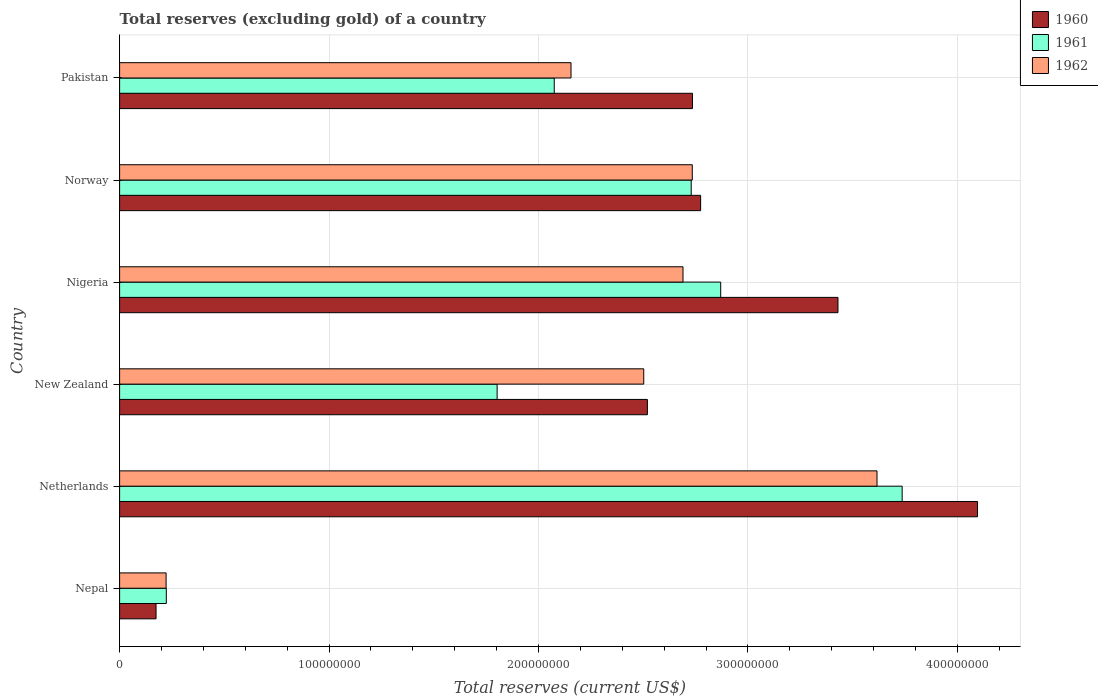Are the number of bars per tick equal to the number of legend labels?
Your response must be concise. Yes. Are the number of bars on each tick of the Y-axis equal?
Provide a succinct answer. Yes. How many bars are there on the 1st tick from the top?
Give a very brief answer. 3. How many bars are there on the 4th tick from the bottom?
Provide a succinct answer. 3. What is the label of the 4th group of bars from the top?
Provide a short and direct response. New Zealand. In how many cases, is the number of bars for a given country not equal to the number of legend labels?
Ensure brevity in your answer.  0. What is the total reserves (excluding gold) in 1960 in Netherlands?
Provide a short and direct response. 4.10e+08. Across all countries, what is the maximum total reserves (excluding gold) in 1960?
Your response must be concise. 4.10e+08. Across all countries, what is the minimum total reserves (excluding gold) in 1960?
Offer a terse response. 1.74e+07. In which country was the total reserves (excluding gold) in 1960 minimum?
Give a very brief answer. Nepal. What is the total total reserves (excluding gold) in 1961 in the graph?
Provide a succinct answer. 1.34e+09. What is the difference between the total reserves (excluding gold) in 1961 in Nepal and that in Netherlands?
Keep it short and to the point. -3.51e+08. What is the difference between the total reserves (excluding gold) in 1961 in New Zealand and the total reserves (excluding gold) in 1962 in Nigeria?
Provide a short and direct response. -8.88e+07. What is the average total reserves (excluding gold) in 1962 per country?
Your response must be concise. 2.32e+08. What is the difference between the total reserves (excluding gold) in 1961 and total reserves (excluding gold) in 1960 in Norway?
Make the answer very short. -4.50e+06. In how many countries, is the total reserves (excluding gold) in 1962 greater than 320000000 US$?
Make the answer very short. 1. What is the ratio of the total reserves (excluding gold) in 1960 in Nepal to that in New Zealand?
Give a very brief answer. 0.07. Is the total reserves (excluding gold) in 1962 in Netherlands less than that in Nigeria?
Offer a terse response. No. What is the difference between the highest and the second highest total reserves (excluding gold) in 1960?
Make the answer very short. 6.66e+07. What is the difference between the highest and the lowest total reserves (excluding gold) in 1961?
Make the answer very short. 3.51e+08. Is the sum of the total reserves (excluding gold) in 1961 in Netherlands and Norway greater than the maximum total reserves (excluding gold) in 1960 across all countries?
Give a very brief answer. Yes. What does the 1st bar from the top in Nigeria represents?
Offer a very short reply. 1962. What does the 3rd bar from the bottom in New Zealand represents?
Provide a succinct answer. 1962. How many bars are there?
Keep it short and to the point. 18. How many countries are there in the graph?
Offer a terse response. 6. What is the difference between two consecutive major ticks on the X-axis?
Offer a very short reply. 1.00e+08. Are the values on the major ticks of X-axis written in scientific E-notation?
Provide a succinct answer. No. Does the graph contain any zero values?
Make the answer very short. No. Does the graph contain grids?
Give a very brief answer. Yes. Where does the legend appear in the graph?
Offer a very short reply. Top right. What is the title of the graph?
Your answer should be compact. Total reserves (excluding gold) of a country. What is the label or title of the X-axis?
Make the answer very short. Total reserves (current US$). What is the Total reserves (current US$) of 1960 in Nepal?
Offer a very short reply. 1.74e+07. What is the Total reserves (current US$) in 1961 in Nepal?
Offer a very short reply. 2.23e+07. What is the Total reserves (current US$) of 1962 in Nepal?
Your answer should be compact. 2.22e+07. What is the Total reserves (current US$) of 1960 in Netherlands?
Ensure brevity in your answer.  4.10e+08. What is the Total reserves (current US$) of 1961 in Netherlands?
Offer a very short reply. 3.74e+08. What is the Total reserves (current US$) in 1962 in Netherlands?
Your answer should be very brief. 3.62e+08. What is the Total reserves (current US$) in 1960 in New Zealand?
Keep it short and to the point. 2.52e+08. What is the Total reserves (current US$) in 1961 in New Zealand?
Offer a terse response. 1.80e+08. What is the Total reserves (current US$) in 1962 in New Zealand?
Offer a very short reply. 2.50e+08. What is the Total reserves (current US$) in 1960 in Nigeria?
Give a very brief answer. 3.43e+08. What is the Total reserves (current US$) in 1961 in Nigeria?
Make the answer very short. 2.87e+08. What is the Total reserves (current US$) of 1962 in Nigeria?
Keep it short and to the point. 2.69e+08. What is the Total reserves (current US$) of 1960 in Norway?
Provide a short and direct response. 2.77e+08. What is the Total reserves (current US$) of 1961 in Norway?
Ensure brevity in your answer.  2.73e+08. What is the Total reserves (current US$) in 1962 in Norway?
Your answer should be compact. 2.73e+08. What is the Total reserves (current US$) in 1960 in Pakistan?
Make the answer very short. 2.74e+08. What is the Total reserves (current US$) in 1961 in Pakistan?
Provide a short and direct response. 2.08e+08. What is the Total reserves (current US$) in 1962 in Pakistan?
Provide a short and direct response. 2.16e+08. Across all countries, what is the maximum Total reserves (current US$) of 1960?
Your answer should be compact. 4.10e+08. Across all countries, what is the maximum Total reserves (current US$) of 1961?
Keep it short and to the point. 3.74e+08. Across all countries, what is the maximum Total reserves (current US$) of 1962?
Keep it short and to the point. 3.62e+08. Across all countries, what is the minimum Total reserves (current US$) in 1960?
Offer a very short reply. 1.74e+07. Across all countries, what is the minimum Total reserves (current US$) of 1961?
Provide a succinct answer. 2.23e+07. Across all countries, what is the minimum Total reserves (current US$) of 1962?
Provide a succinct answer. 2.22e+07. What is the total Total reserves (current US$) of 1960 in the graph?
Make the answer very short. 1.57e+09. What is the total Total reserves (current US$) in 1961 in the graph?
Provide a short and direct response. 1.34e+09. What is the total Total reserves (current US$) of 1962 in the graph?
Your answer should be compact. 1.39e+09. What is the difference between the Total reserves (current US$) of 1960 in Nepal and that in Netherlands?
Your answer should be compact. -3.92e+08. What is the difference between the Total reserves (current US$) of 1961 in Nepal and that in Netherlands?
Offer a very short reply. -3.51e+08. What is the difference between the Total reserves (current US$) of 1962 in Nepal and that in Netherlands?
Your answer should be compact. -3.39e+08. What is the difference between the Total reserves (current US$) in 1960 in Nepal and that in New Zealand?
Make the answer very short. -2.35e+08. What is the difference between the Total reserves (current US$) in 1961 in Nepal and that in New Zealand?
Provide a succinct answer. -1.58e+08. What is the difference between the Total reserves (current US$) in 1962 in Nepal and that in New Zealand?
Keep it short and to the point. -2.28e+08. What is the difference between the Total reserves (current US$) in 1960 in Nepal and that in Nigeria?
Your answer should be very brief. -3.26e+08. What is the difference between the Total reserves (current US$) of 1961 in Nepal and that in Nigeria?
Provide a succinct answer. -2.65e+08. What is the difference between the Total reserves (current US$) of 1962 in Nepal and that in Nigeria?
Provide a succinct answer. -2.47e+08. What is the difference between the Total reserves (current US$) in 1960 in Nepal and that in Norway?
Give a very brief answer. -2.60e+08. What is the difference between the Total reserves (current US$) in 1961 in Nepal and that in Norway?
Provide a short and direct response. -2.51e+08. What is the difference between the Total reserves (current US$) in 1962 in Nepal and that in Norway?
Make the answer very short. -2.51e+08. What is the difference between the Total reserves (current US$) in 1960 in Nepal and that in Pakistan?
Keep it short and to the point. -2.56e+08. What is the difference between the Total reserves (current US$) in 1961 in Nepal and that in Pakistan?
Provide a short and direct response. -1.85e+08. What is the difference between the Total reserves (current US$) in 1962 in Nepal and that in Pakistan?
Make the answer very short. -1.93e+08. What is the difference between the Total reserves (current US$) in 1960 in Netherlands and that in New Zealand?
Make the answer very short. 1.58e+08. What is the difference between the Total reserves (current US$) in 1961 in Netherlands and that in New Zealand?
Make the answer very short. 1.93e+08. What is the difference between the Total reserves (current US$) in 1962 in Netherlands and that in New Zealand?
Your response must be concise. 1.11e+08. What is the difference between the Total reserves (current US$) in 1960 in Netherlands and that in Nigeria?
Keep it short and to the point. 6.66e+07. What is the difference between the Total reserves (current US$) in 1961 in Netherlands and that in Nigeria?
Provide a short and direct response. 8.66e+07. What is the difference between the Total reserves (current US$) of 1962 in Netherlands and that in Nigeria?
Ensure brevity in your answer.  9.26e+07. What is the difference between the Total reserves (current US$) of 1960 in Netherlands and that in Norway?
Your response must be concise. 1.32e+08. What is the difference between the Total reserves (current US$) in 1961 in Netherlands and that in Norway?
Your response must be concise. 1.01e+08. What is the difference between the Total reserves (current US$) of 1962 in Netherlands and that in Norway?
Your response must be concise. 8.82e+07. What is the difference between the Total reserves (current US$) in 1960 in Netherlands and that in Pakistan?
Provide a short and direct response. 1.36e+08. What is the difference between the Total reserves (current US$) in 1961 in Netherlands and that in Pakistan?
Keep it short and to the point. 1.66e+08. What is the difference between the Total reserves (current US$) of 1962 in Netherlands and that in Pakistan?
Offer a very short reply. 1.46e+08. What is the difference between the Total reserves (current US$) of 1960 in New Zealand and that in Nigeria?
Provide a succinct answer. -9.10e+07. What is the difference between the Total reserves (current US$) of 1961 in New Zealand and that in Nigeria?
Keep it short and to the point. -1.07e+08. What is the difference between the Total reserves (current US$) of 1962 in New Zealand and that in Nigeria?
Your response must be concise. -1.87e+07. What is the difference between the Total reserves (current US$) in 1960 in New Zealand and that in Norway?
Your answer should be very brief. -2.54e+07. What is the difference between the Total reserves (current US$) in 1961 in New Zealand and that in Norway?
Provide a succinct answer. -9.27e+07. What is the difference between the Total reserves (current US$) in 1962 in New Zealand and that in Norway?
Provide a succinct answer. -2.32e+07. What is the difference between the Total reserves (current US$) in 1960 in New Zealand and that in Pakistan?
Your answer should be compact. -2.15e+07. What is the difference between the Total reserves (current US$) of 1961 in New Zealand and that in Pakistan?
Give a very brief answer. -2.73e+07. What is the difference between the Total reserves (current US$) of 1962 in New Zealand and that in Pakistan?
Your response must be concise. 3.47e+07. What is the difference between the Total reserves (current US$) in 1960 in Nigeria and that in Norway?
Give a very brief answer. 6.56e+07. What is the difference between the Total reserves (current US$) of 1961 in Nigeria and that in Norway?
Provide a short and direct response. 1.41e+07. What is the difference between the Total reserves (current US$) in 1962 in Nigeria and that in Norway?
Offer a terse response. -4.43e+06. What is the difference between the Total reserves (current US$) in 1960 in Nigeria and that in Pakistan?
Offer a terse response. 6.95e+07. What is the difference between the Total reserves (current US$) in 1961 in Nigeria and that in Pakistan?
Offer a terse response. 7.95e+07. What is the difference between the Total reserves (current US$) in 1962 in Nigeria and that in Pakistan?
Offer a very short reply. 5.35e+07. What is the difference between the Total reserves (current US$) in 1960 in Norway and that in Pakistan?
Your response must be concise. 3.90e+06. What is the difference between the Total reserves (current US$) in 1961 in Norway and that in Pakistan?
Give a very brief answer. 6.54e+07. What is the difference between the Total reserves (current US$) in 1962 in Norway and that in Pakistan?
Make the answer very short. 5.79e+07. What is the difference between the Total reserves (current US$) of 1960 in Nepal and the Total reserves (current US$) of 1961 in Netherlands?
Ensure brevity in your answer.  -3.56e+08. What is the difference between the Total reserves (current US$) of 1960 in Nepal and the Total reserves (current US$) of 1962 in Netherlands?
Offer a very short reply. -3.44e+08. What is the difference between the Total reserves (current US$) in 1961 in Nepal and the Total reserves (current US$) in 1962 in Netherlands?
Provide a succinct answer. -3.39e+08. What is the difference between the Total reserves (current US$) in 1960 in Nepal and the Total reserves (current US$) in 1961 in New Zealand?
Offer a terse response. -1.63e+08. What is the difference between the Total reserves (current US$) of 1960 in Nepal and the Total reserves (current US$) of 1962 in New Zealand?
Your response must be concise. -2.33e+08. What is the difference between the Total reserves (current US$) in 1961 in Nepal and the Total reserves (current US$) in 1962 in New Zealand?
Provide a succinct answer. -2.28e+08. What is the difference between the Total reserves (current US$) in 1960 in Nepal and the Total reserves (current US$) in 1961 in Nigeria?
Make the answer very short. -2.70e+08. What is the difference between the Total reserves (current US$) in 1960 in Nepal and the Total reserves (current US$) in 1962 in Nigeria?
Keep it short and to the point. -2.52e+08. What is the difference between the Total reserves (current US$) in 1961 in Nepal and the Total reserves (current US$) in 1962 in Nigeria?
Your answer should be very brief. -2.47e+08. What is the difference between the Total reserves (current US$) of 1960 in Nepal and the Total reserves (current US$) of 1961 in Norway?
Provide a short and direct response. -2.56e+08. What is the difference between the Total reserves (current US$) in 1960 in Nepal and the Total reserves (current US$) in 1962 in Norway?
Your response must be concise. -2.56e+08. What is the difference between the Total reserves (current US$) in 1961 in Nepal and the Total reserves (current US$) in 1962 in Norway?
Your answer should be very brief. -2.51e+08. What is the difference between the Total reserves (current US$) of 1960 in Nepal and the Total reserves (current US$) of 1961 in Pakistan?
Your response must be concise. -1.90e+08. What is the difference between the Total reserves (current US$) of 1960 in Nepal and the Total reserves (current US$) of 1962 in Pakistan?
Your answer should be very brief. -1.98e+08. What is the difference between the Total reserves (current US$) in 1961 in Nepal and the Total reserves (current US$) in 1962 in Pakistan?
Make the answer very short. -1.93e+08. What is the difference between the Total reserves (current US$) in 1960 in Netherlands and the Total reserves (current US$) in 1961 in New Zealand?
Give a very brief answer. 2.29e+08. What is the difference between the Total reserves (current US$) in 1960 in Netherlands and the Total reserves (current US$) in 1962 in New Zealand?
Provide a succinct answer. 1.59e+08. What is the difference between the Total reserves (current US$) in 1961 in Netherlands and the Total reserves (current US$) in 1962 in New Zealand?
Provide a short and direct response. 1.23e+08. What is the difference between the Total reserves (current US$) in 1960 in Netherlands and the Total reserves (current US$) in 1961 in Nigeria?
Make the answer very short. 1.23e+08. What is the difference between the Total reserves (current US$) in 1960 in Netherlands and the Total reserves (current US$) in 1962 in Nigeria?
Keep it short and to the point. 1.41e+08. What is the difference between the Total reserves (current US$) in 1961 in Netherlands and the Total reserves (current US$) in 1962 in Nigeria?
Keep it short and to the point. 1.05e+08. What is the difference between the Total reserves (current US$) of 1960 in Netherlands and the Total reserves (current US$) of 1961 in Norway?
Make the answer very short. 1.37e+08. What is the difference between the Total reserves (current US$) in 1960 in Netherlands and the Total reserves (current US$) in 1962 in Norway?
Offer a very short reply. 1.36e+08. What is the difference between the Total reserves (current US$) in 1961 in Netherlands and the Total reserves (current US$) in 1962 in Norway?
Provide a short and direct response. 1.00e+08. What is the difference between the Total reserves (current US$) in 1960 in Netherlands and the Total reserves (current US$) in 1961 in Pakistan?
Your answer should be very brief. 2.02e+08. What is the difference between the Total reserves (current US$) in 1960 in Netherlands and the Total reserves (current US$) in 1962 in Pakistan?
Provide a succinct answer. 1.94e+08. What is the difference between the Total reserves (current US$) in 1961 in Netherlands and the Total reserves (current US$) in 1962 in Pakistan?
Provide a short and direct response. 1.58e+08. What is the difference between the Total reserves (current US$) in 1960 in New Zealand and the Total reserves (current US$) in 1961 in Nigeria?
Make the answer very short. -3.50e+07. What is the difference between the Total reserves (current US$) in 1960 in New Zealand and the Total reserves (current US$) in 1962 in Nigeria?
Make the answer very short. -1.70e+07. What is the difference between the Total reserves (current US$) of 1961 in New Zealand and the Total reserves (current US$) of 1962 in Nigeria?
Your answer should be compact. -8.88e+07. What is the difference between the Total reserves (current US$) of 1960 in New Zealand and the Total reserves (current US$) of 1961 in Norway?
Provide a succinct answer. -2.09e+07. What is the difference between the Total reserves (current US$) of 1960 in New Zealand and the Total reserves (current US$) of 1962 in Norway?
Your response must be concise. -2.14e+07. What is the difference between the Total reserves (current US$) of 1961 in New Zealand and the Total reserves (current US$) of 1962 in Norway?
Keep it short and to the point. -9.32e+07. What is the difference between the Total reserves (current US$) of 1960 in New Zealand and the Total reserves (current US$) of 1961 in Pakistan?
Offer a terse response. 4.45e+07. What is the difference between the Total reserves (current US$) in 1960 in New Zealand and the Total reserves (current US$) in 1962 in Pakistan?
Provide a short and direct response. 3.65e+07. What is the difference between the Total reserves (current US$) in 1961 in New Zealand and the Total reserves (current US$) in 1962 in Pakistan?
Offer a very short reply. -3.53e+07. What is the difference between the Total reserves (current US$) in 1960 in Nigeria and the Total reserves (current US$) in 1961 in Norway?
Keep it short and to the point. 7.01e+07. What is the difference between the Total reserves (current US$) of 1960 in Nigeria and the Total reserves (current US$) of 1962 in Norway?
Ensure brevity in your answer.  6.96e+07. What is the difference between the Total reserves (current US$) in 1961 in Nigeria and the Total reserves (current US$) in 1962 in Norway?
Give a very brief answer. 1.36e+07. What is the difference between the Total reserves (current US$) of 1960 in Nigeria and the Total reserves (current US$) of 1961 in Pakistan?
Your answer should be compact. 1.35e+08. What is the difference between the Total reserves (current US$) of 1960 in Nigeria and the Total reserves (current US$) of 1962 in Pakistan?
Your answer should be very brief. 1.27e+08. What is the difference between the Total reserves (current US$) of 1961 in Nigeria and the Total reserves (current US$) of 1962 in Pakistan?
Keep it short and to the point. 7.15e+07. What is the difference between the Total reserves (current US$) in 1960 in Norway and the Total reserves (current US$) in 1961 in Pakistan?
Your answer should be compact. 6.99e+07. What is the difference between the Total reserves (current US$) of 1960 in Norway and the Total reserves (current US$) of 1962 in Pakistan?
Offer a very short reply. 6.19e+07. What is the difference between the Total reserves (current US$) in 1961 in Norway and the Total reserves (current US$) in 1962 in Pakistan?
Provide a succinct answer. 5.74e+07. What is the average Total reserves (current US$) in 1960 per country?
Your response must be concise. 2.62e+08. What is the average Total reserves (current US$) in 1961 per country?
Provide a succinct answer. 2.24e+08. What is the average Total reserves (current US$) in 1962 per country?
Provide a succinct answer. 2.32e+08. What is the difference between the Total reserves (current US$) of 1960 and Total reserves (current US$) of 1961 in Nepal?
Give a very brief answer. -4.90e+06. What is the difference between the Total reserves (current US$) of 1960 and Total reserves (current US$) of 1962 in Nepal?
Your answer should be very brief. -4.80e+06. What is the difference between the Total reserves (current US$) in 1961 and Total reserves (current US$) in 1962 in Nepal?
Your response must be concise. 1.00e+05. What is the difference between the Total reserves (current US$) in 1960 and Total reserves (current US$) in 1961 in Netherlands?
Your answer should be very brief. 3.60e+07. What is the difference between the Total reserves (current US$) of 1960 and Total reserves (current US$) of 1962 in Netherlands?
Your response must be concise. 4.80e+07. What is the difference between the Total reserves (current US$) of 1961 and Total reserves (current US$) of 1962 in Netherlands?
Your answer should be compact. 1.20e+07. What is the difference between the Total reserves (current US$) of 1960 and Total reserves (current US$) of 1961 in New Zealand?
Provide a short and direct response. 7.18e+07. What is the difference between the Total reserves (current US$) in 1960 and Total reserves (current US$) in 1962 in New Zealand?
Keep it short and to the point. 1.74e+06. What is the difference between the Total reserves (current US$) in 1961 and Total reserves (current US$) in 1962 in New Zealand?
Offer a very short reply. -7.00e+07. What is the difference between the Total reserves (current US$) in 1960 and Total reserves (current US$) in 1961 in Nigeria?
Give a very brief answer. 5.60e+07. What is the difference between the Total reserves (current US$) in 1960 and Total reserves (current US$) in 1962 in Nigeria?
Make the answer very short. 7.40e+07. What is the difference between the Total reserves (current US$) in 1961 and Total reserves (current US$) in 1962 in Nigeria?
Give a very brief answer. 1.80e+07. What is the difference between the Total reserves (current US$) of 1960 and Total reserves (current US$) of 1961 in Norway?
Your response must be concise. 4.50e+06. What is the difference between the Total reserves (current US$) in 1960 and Total reserves (current US$) in 1962 in Norway?
Give a very brief answer. 3.99e+06. What is the difference between the Total reserves (current US$) of 1961 and Total reserves (current US$) of 1962 in Norway?
Give a very brief answer. -5.10e+05. What is the difference between the Total reserves (current US$) of 1960 and Total reserves (current US$) of 1961 in Pakistan?
Your response must be concise. 6.60e+07. What is the difference between the Total reserves (current US$) of 1960 and Total reserves (current US$) of 1962 in Pakistan?
Ensure brevity in your answer.  5.80e+07. What is the difference between the Total reserves (current US$) of 1961 and Total reserves (current US$) of 1962 in Pakistan?
Keep it short and to the point. -8.00e+06. What is the ratio of the Total reserves (current US$) in 1960 in Nepal to that in Netherlands?
Your answer should be very brief. 0.04. What is the ratio of the Total reserves (current US$) in 1961 in Nepal to that in Netherlands?
Provide a succinct answer. 0.06. What is the ratio of the Total reserves (current US$) of 1962 in Nepal to that in Netherlands?
Ensure brevity in your answer.  0.06. What is the ratio of the Total reserves (current US$) of 1960 in Nepal to that in New Zealand?
Provide a succinct answer. 0.07. What is the ratio of the Total reserves (current US$) in 1961 in Nepal to that in New Zealand?
Your answer should be very brief. 0.12. What is the ratio of the Total reserves (current US$) of 1962 in Nepal to that in New Zealand?
Provide a succinct answer. 0.09. What is the ratio of the Total reserves (current US$) of 1960 in Nepal to that in Nigeria?
Ensure brevity in your answer.  0.05. What is the ratio of the Total reserves (current US$) of 1961 in Nepal to that in Nigeria?
Give a very brief answer. 0.08. What is the ratio of the Total reserves (current US$) in 1962 in Nepal to that in Nigeria?
Your answer should be compact. 0.08. What is the ratio of the Total reserves (current US$) of 1960 in Nepal to that in Norway?
Your response must be concise. 0.06. What is the ratio of the Total reserves (current US$) in 1961 in Nepal to that in Norway?
Your answer should be very brief. 0.08. What is the ratio of the Total reserves (current US$) in 1962 in Nepal to that in Norway?
Ensure brevity in your answer.  0.08. What is the ratio of the Total reserves (current US$) of 1960 in Nepal to that in Pakistan?
Offer a very short reply. 0.06. What is the ratio of the Total reserves (current US$) in 1961 in Nepal to that in Pakistan?
Ensure brevity in your answer.  0.11. What is the ratio of the Total reserves (current US$) in 1962 in Nepal to that in Pakistan?
Provide a short and direct response. 0.1. What is the ratio of the Total reserves (current US$) in 1960 in Netherlands to that in New Zealand?
Ensure brevity in your answer.  1.63. What is the ratio of the Total reserves (current US$) of 1961 in Netherlands to that in New Zealand?
Your answer should be compact. 2.07. What is the ratio of the Total reserves (current US$) of 1962 in Netherlands to that in New Zealand?
Your answer should be compact. 1.45. What is the ratio of the Total reserves (current US$) of 1960 in Netherlands to that in Nigeria?
Your answer should be compact. 1.19. What is the ratio of the Total reserves (current US$) in 1961 in Netherlands to that in Nigeria?
Your answer should be very brief. 1.3. What is the ratio of the Total reserves (current US$) of 1962 in Netherlands to that in Nigeria?
Give a very brief answer. 1.34. What is the ratio of the Total reserves (current US$) in 1960 in Netherlands to that in Norway?
Ensure brevity in your answer.  1.48. What is the ratio of the Total reserves (current US$) of 1961 in Netherlands to that in Norway?
Keep it short and to the point. 1.37. What is the ratio of the Total reserves (current US$) of 1962 in Netherlands to that in Norway?
Make the answer very short. 1.32. What is the ratio of the Total reserves (current US$) in 1960 in Netherlands to that in Pakistan?
Offer a terse response. 1.5. What is the ratio of the Total reserves (current US$) of 1961 in Netherlands to that in Pakistan?
Provide a succinct answer. 1.8. What is the ratio of the Total reserves (current US$) in 1962 in Netherlands to that in Pakistan?
Provide a succinct answer. 1.68. What is the ratio of the Total reserves (current US$) in 1960 in New Zealand to that in Nigeria?
Your answer should be very brief. 0.73. What is the ratio of the Total reserves (current US$) in 1961 in New Zealand to that in Nigeria?
Your answer should be very brief. 0.63. What is the ratio of the Total reserves (current US$) in 1962 in New Zealand to that in Nigeria?
Your answer should be compact. 0.93. What is the ratio of the Total reserves (current US$) in 1960 in New Zealand to that in Norway?
Offer a very short reply. 0.91. What is the ratio of the Total reserves (current US$) of 1961 in New Zealand to that in Norway?
Ensure brevity in your answer.  0.66. What is the ratio of the Total reserves (current US$) of 1962 in New Zealand to that in Norway?
Provide a succinct answer. 0.92. What is the ratio of the Total reserves (current US$) in 1960 in New Zealand to that in Pakistan?
Give a very brief answer. 0.92. What is the ratio of the Total reserves (current US$) in 1961 in New Zealand to that in Pakistan?
Provide a succinct answer. 0.87. What is the ratio of the Total reserves (current US$) of 1962 in New Zealand to that in Pakistan?
Make the answer very short. 1.16. What is the ratio of the Total reserves (current US$) of 1960 in Nigeria to that in Norway?
Give a very brief answer. 1.24. What is the ratio of the Total reserves (current US$) of 1961 in Nigeria to that in Norway?
Make the answer very short. 1.05. What is the ratio of the Total reserves (current US$) in 1962 in Nigeria to that in Norway?
Ensure brevity in your answer.  0.98. What is the ratio of the Total reserves (current US$) of 1960 in Nigeria to that in Pakistan?
Give a very brief answer. 1.25. What is the ratio of the Total reserves (current US$) of 1961 in Nigeria to that in Pakistan?
Ensure brevity in your answer.  1.38. What is the ratio of the Total reserves (current US$) of 1962 in Nigeria to that in Pakistan?
Your response must be concise. 1.25. What is the ratio of the Total reserves (current US$) of 1960 in Norway to that in Pakistan?
Your answer should be very brief. 1.01. What is the ratio of the Total reserves (current US$) of 1961 in Norway to that in Pakistan?
Ensure brevity in your answer.  1.32. What is the ratio of the Total reserves (current US$) in 1962 in Norway to that in Pakistan?
Provide a succinct answer. 1.27. What is the difference between the highest and the second highest Total reserves (current US$) of 1960?
Offer a very short reply. 6.66e+07. What is the difference between the highest and the second highest Total reserves (current US$) in 1961?
Your response must be concise. 8.66e+07. What is the difference between the highest and the second highest Total reserves (current US$) in 1962?
Keep it short and to the point. 8.82e+07. What is the difference between the highest and the lowest Total reserves (current US$) in 1960?
Provide a succinct answer. 3.92e+08. What is the difference between the highest and the lowest Total reserves (current US$) in 1961?
Provide a succinct answer. 3.51e+08. What is the difference between the highest and the lowest Total reserves (current US$) of 1962?
Make the answer very short. 3.39e+08. 